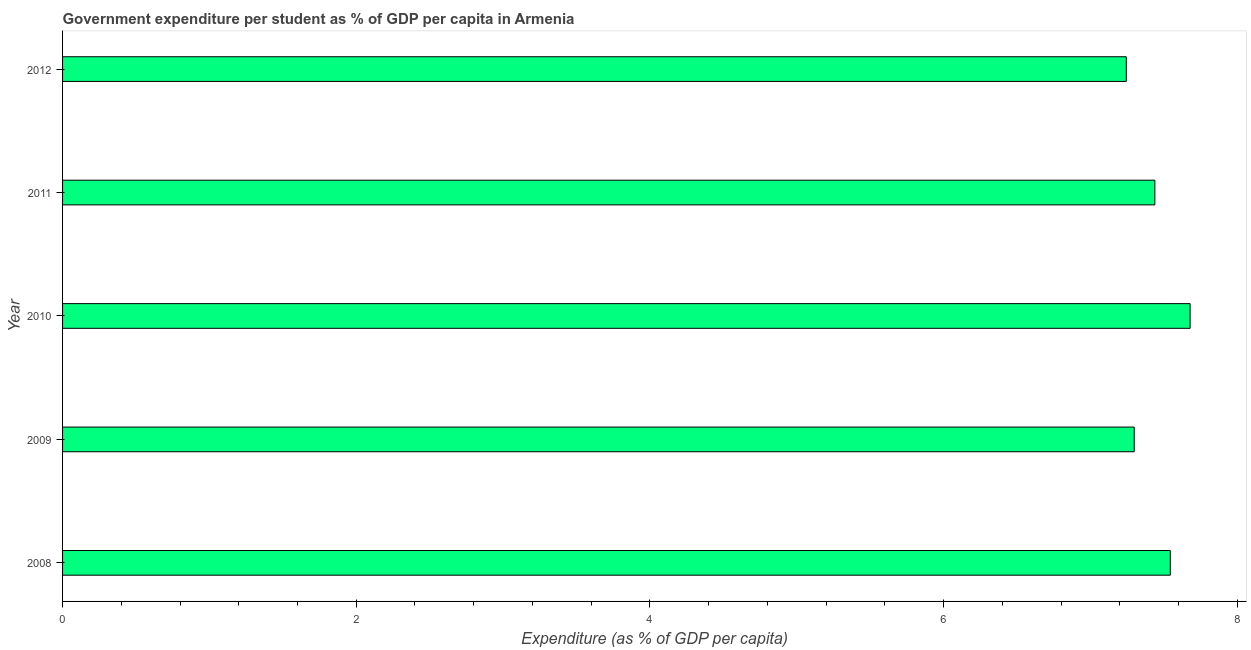Does the graph contain grids?
Your answer should be compact. No. What is the title of the graph?
Provide a succinct answer. Government expenditure per student as % of GDP per capita in Armenia. What is the label or title of the X-axis?
Provide a short and direct response. Expenditure (as % of GDP per capita). What is the label or title of the Y-axis?
Your answer should be compact. Year. What is the government expenditure per student in 2010?
Provide a short and direct response. 7.68. Across all years, what is the maximum government expenditure per student?
Keep it short and to the point. 7.68. Across all years, what is the minimum government expenditure per student?
Ensure brevity in your answer.  7.24. In which year was the government expenditure per student minimum?
Offer a terse response. 2012. What is the sum of the government expenditure per student?
Your response must be concise. 37.2. What is the difference between the government expenditure per student in 2008 and 2012?
Ensure brevity in your answer.  0.3. What is the average government expenditure per student per year?
Ensure brevity in your answer.  7.44. What is the median government expenditure per student?
Your answer should be very brief. 7.44. In how many years, is the government expenditure per student greater than 7.2 %?
Your answer should be very brief. 5. Do a majority of the years between 2009 and 2011 (inclusive) have government expenditure per student greater than 6.8 %?
Ensure brevity in your answer.  Yes. What is the ratio of the government expenditure per student in 2008 to that in 2009?
Give a very brief answer. 1.03. Is the government expenditure per student in 2009 less than that in 2012?
Provide a short and direct response. No. Is the difference between the government expenditure per student in 2009 and 2011 greater than the difference between any two years?
Offer a terse response. No. What is the difference between the highest and the second highest government expenditure per student?
Offer a terse response. 0.14. Is the sum of the government expenditure per student in 2008 and 2009 greater than the maximum government expenditure per student across all years?
Offer a very short reply. Yes. What is the difference between the highest and the lowest government expenditure per student?
Provide a short and direct response. 0.43. In how many years, is the government expenditure per student greater than the average government expenditure per student taken over all years?
Offer a terse response. 2. Are all the bars in the graph horizontal?
Your answer should be very brief. Yes. How many years are there in the graph?
Offer a very short reply. 5. What is the Expenditure (as % of GDP per capita) of 2008?
Keep it short and to the point. 7.54. What is the Expenditure (as % of GDP per capita) of 2009?
Offer a very short reply. 7.3. What is the Expenditure (as % of GDP per capita) in 2010?
Provide a succinct answer. 7.68. What is the Expenditure (as % of GDP per capita) in 2011?
Keep it short and to the point. 7.44. What is the Expenditure (as % of GDP per capita) in 2012?
Give a very brief answer. 7.24. What is the difference between the Expenditure (as % of GDP per capita) in 2008 and 2009?
Offer a terse response. 0.25. What is the difference between the Expenditure (as % of GDP per capita) in 2008 and 2010?
Make the answer very short. -0.14. What is the difference between the Expenditure (as % of GDP per capita) in 2008 and 2011?
Provide a short and direct response. 0.11. What is the difference between the Expenditure (as % of GDP per capita) in 2008 and 2012?
Provide a short and direct response. 0.3. What is the difference between the Expenditure (as % of GDP per capita) in 2009 and 2010?
Offer a terse response. -0.38. What is the difference between the Expenditure (as % of GDP per capita) in 2009 and 2011?
Give a very brief answer. -0.14. What is the difference between the Expenditure (as % of GDP per capita) in 2009 and 2012?
Give a very brief answer. 0.05. What is the difference between the Expenditure (as % of GDP per capita) in 2010 and 2011?
Make the answer very short. 0.24. What is the difference between the Expenditure (as % of GDP per capita) in 2010 and 2012?
Your answer should be compact. 0.43. What is the difference between the Expenditure (as % of GDP per capita) in 2011 and 2012?
Give a very brief answer. 0.19. What is the ratio of the Expenditure (as % of GDP per capita) in 2008 to that in 2009?
Make the answer very short. 1.03. What is the ratio of the Expenditure (as % of GDP per capita) in 2008 to that in 2012?
Keep it short and to the point. 1.04. What is the ratio of the Expenditure (as % of GDP per capita) in 2009 to that in 2010?
Offer a very short reply. 0.95. What is the ratio of the Expenditure (as % of GDP per capita) in 2009 to that in 2012?
Give a very brief answer. 1.01. What is the ratio of the Expenditure (as % of GDP per capita) in 2010 to that in 2011?
Make the answer very short. 1.03. What is the ratio of the Expenditure (as % of GDP per capita) in 2010 to that in 2012?
Make the answer very short. 1.06. What is the ratio of the Expenditure (as % of GDP per capita) in 2011 to that in 2012?
Offer a terse response. 1.03. 